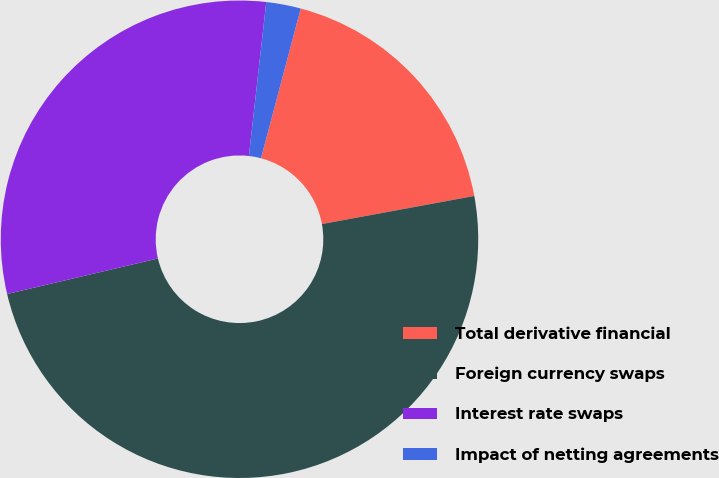<chart> <loc_0><loc_0><loc_500><loc_500><pie_chart><fcel>Total derivative financial<fcel>Foreign currency swaps<fcel>Interest rate swaps<fcel>Impact of netting agreements<nl><fcel>17.97%<fcel>49.22%<fcel>30.47%<fcel>2.34%<nl></chart> 